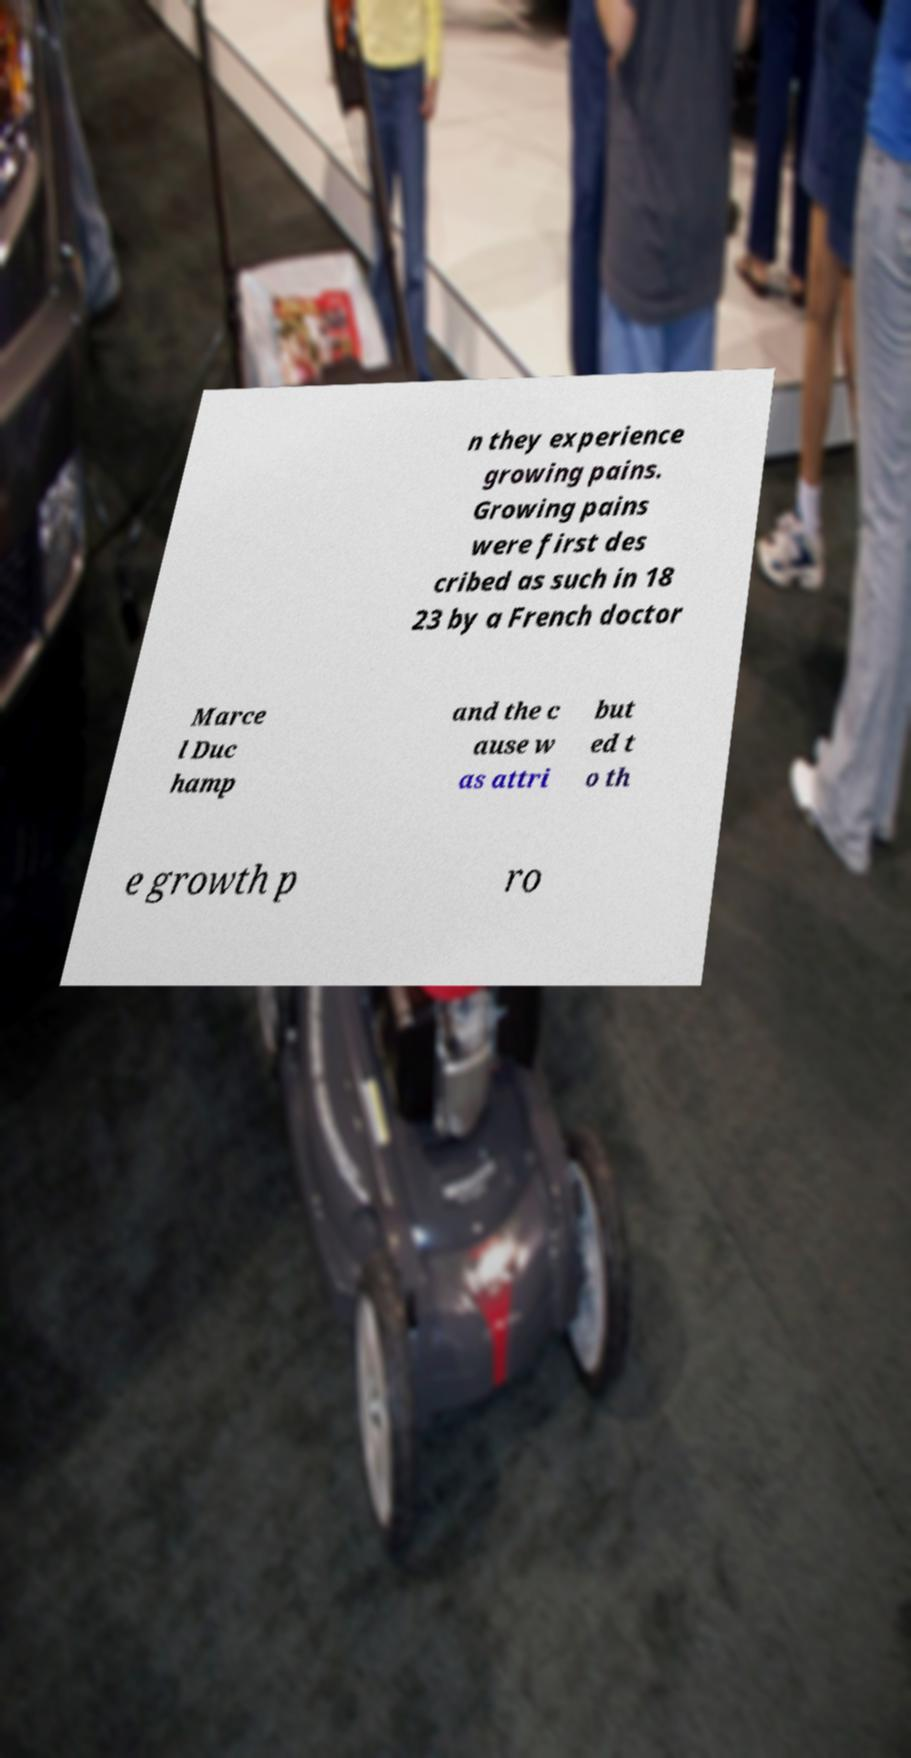Could you assist in decoding the text presented in this image and type it out clearly? n they experience growing pains. Growing pains were first des cribed as such in 18 23 by a French doctor Marce l Duc hamp and the c ause w as attri but ed t o th e growth p ro 